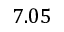Convert formula to latex. <formula><loc_0><loc_0><loc_500><loc_500>7 . 0 5</formula> 